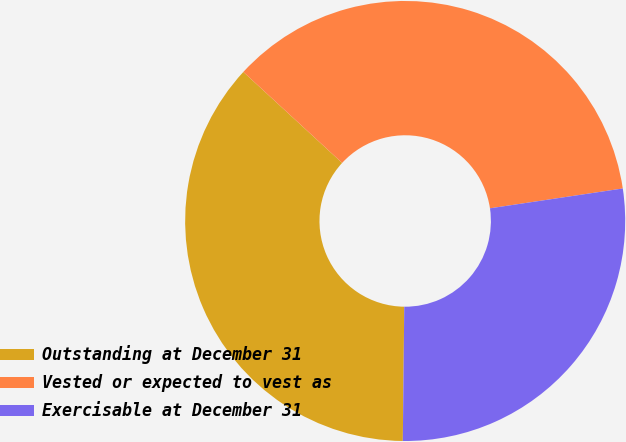Convert chart. <chart><loc_0><loc_0><loc_500><loc_500><pie_chart><fcel>Outstanding at December 31<fcel>Vested or expected to vest as<fcel>Exercisable at December 31<nl><fcel>36.67%<fcel>35.79%<fcel>27.53%<nl></chart> 